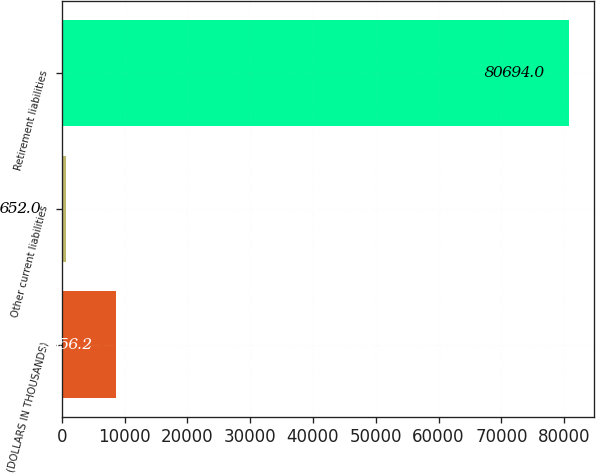<chart> <loc_0><loc_0><loc_500><loc_500><bar_chart><fcel>(DOLLARS IN THOUSANDS)<fcel>Other current liabilities<fcel>Retirement liabilities<nl><fcel>8656.2<fcel>652<fcel>80694<nl></chart> 